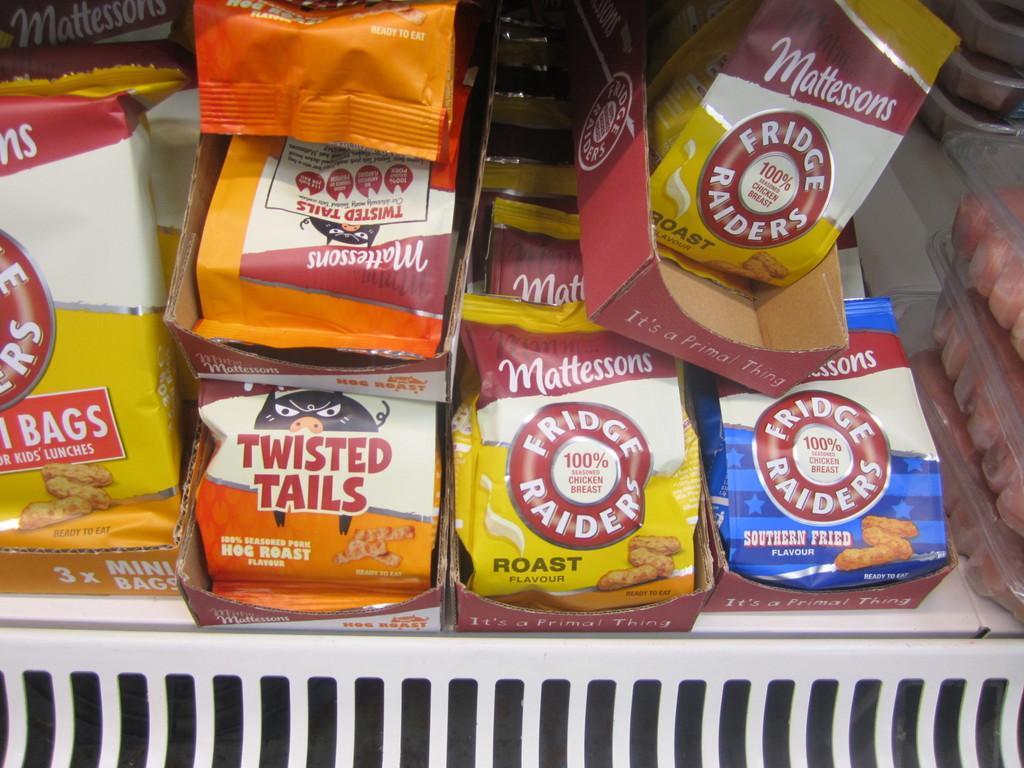Please provide a concise description of this image. In this picture there are snack wrappers in the center of the image, inside the rack and there are candy boxes on the right side of the image. 